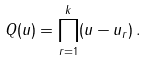<formula> <loc_0><loc_0><loc_500><loc_500>Q ( u ) = \prod _ { r = 1 } ^ { k } ( u - u _ { r } ) \, .</formula> 